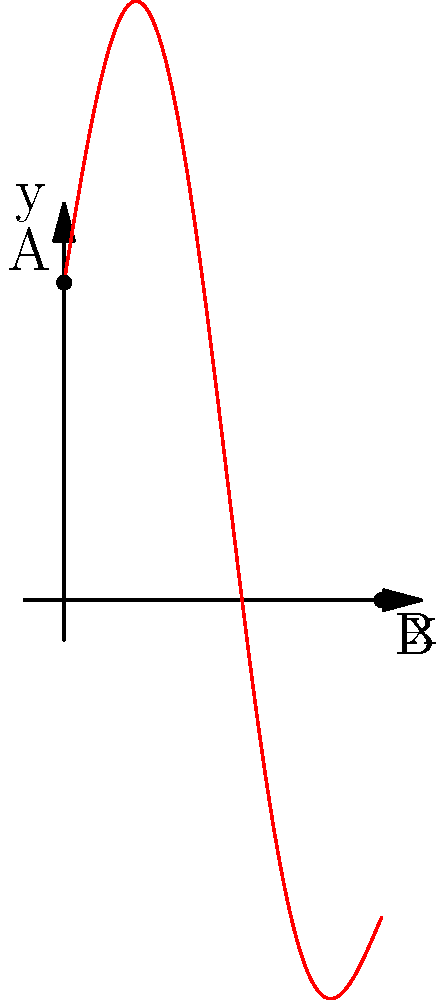A ball is dropped from point A and bounces to point B as shown in the diagram. Assuming ideal conditions and neglecting air resistance, what is the initial velocity of the ball at point A? To solve this problem, we'll use the principles of energy conservation and kinematics. Let's approach this step-by-step:

1. Identify the given information:
   - The ball starts at point A (height h) and ends at point B (ground level)
   - The horizontal distance traveled is x

2. Apply the principle of energy conservation:
   - At point A, the ball has only potential energy
   - At point B, the ball has only kinetic energy
   - The total energy remains constant

3. Calculate the potential energy at point A:
   $PE_A = mgh$, where m is mass, g is acceleration due to gravity, and h is height

4. Calculate the kinetic energy at point B:
   $KE_B = \frac{1}{2}mv^2$, where v is the final velocity at point B

5. Apply energy conservation:
   $PE_A = KE_B$
   $mgh = \frac{1}{2}mv^2$

6. Solve for v:
   $v = \sqrt{2gh}$

7. Use kinematics to relate the initial velocity (v₀) to the final velocity (v):
   $v^2 = v_0^2 + 2gh$

8. Substitute the expression for v from step 6:
   $2gh = v_0^2 + 2gh$

9. Solve for v₀:
   $v_0 = 0$

Therefore, the initial velocity of the ball at point A is zero. This makes sense because the ball is simply dropped, not thrown downward.
Answer: 0 m/s 